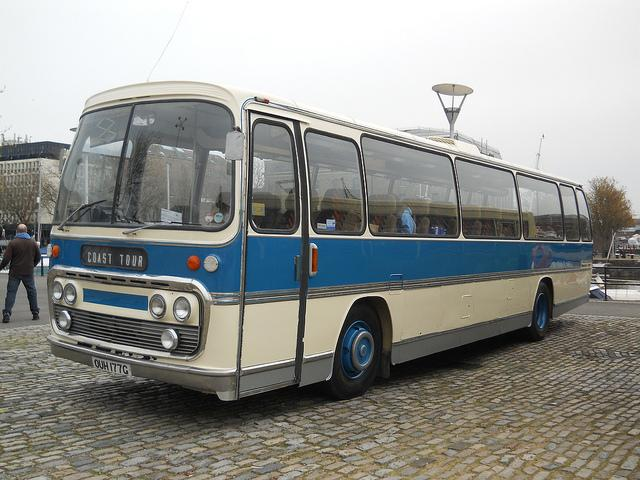What service is being offered for riders on the blue and white bus? Please explain your reasoning. tours. This is a tour bus. 